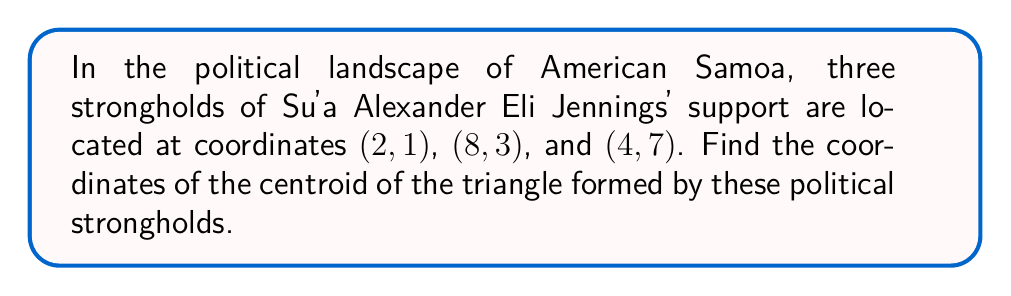Can you answer this question? To find the centroid of a triangle, we need to follow these steps:

1. The centroid of a triangle is located at the intersection of its medians.
2. The coordinates of the centroid can be calculated by averaging the x-coordinates and y-coordinates of the three vertices separately.

Let's denote the three vertices as:
$A(2, 1)$, $B(8, 3)$, and $C(4, 7)$

The formula for the centroid $(x_c, y_c)$ is:

$$x_c = \frac{x_A + x_B + x_C}{3}$$
$$y_c = \frac{y_A + y_B + y_C}{3}$$

Substituting the values:

$$x_c = \frac{2 + 8 + 4}{3} = \frac{14}{3} \approx 4.67$$
$$y_c = \frac{1 + 3 + 7}{3} = \frac{11}{3} \approx 3.67$$

Therefore, the coordinates of the centroid are $(\frac{14}{3}, \frac{11}{3})$.

[asy]
unitsize(20);
pair A = (2,1), B = (8,3), C = (4,7);
pair G = (14/3, 11/3);
draw(A--B--C--cycle, black);
dot("A", A, SW);
dot("B", B, SE);
dot("C", C, N);
dot("G", G, NE);
label("(2, 1)", A, SW);
label("(8, 3)", B, SE);
label("(4, 7)", C, N);
label("($\frac{14}{3}$, $\frac{11}{3}$)", G, NE);
[/asy]
Answer: $(\frac{14}{3}, \frac{11}{3})$ 